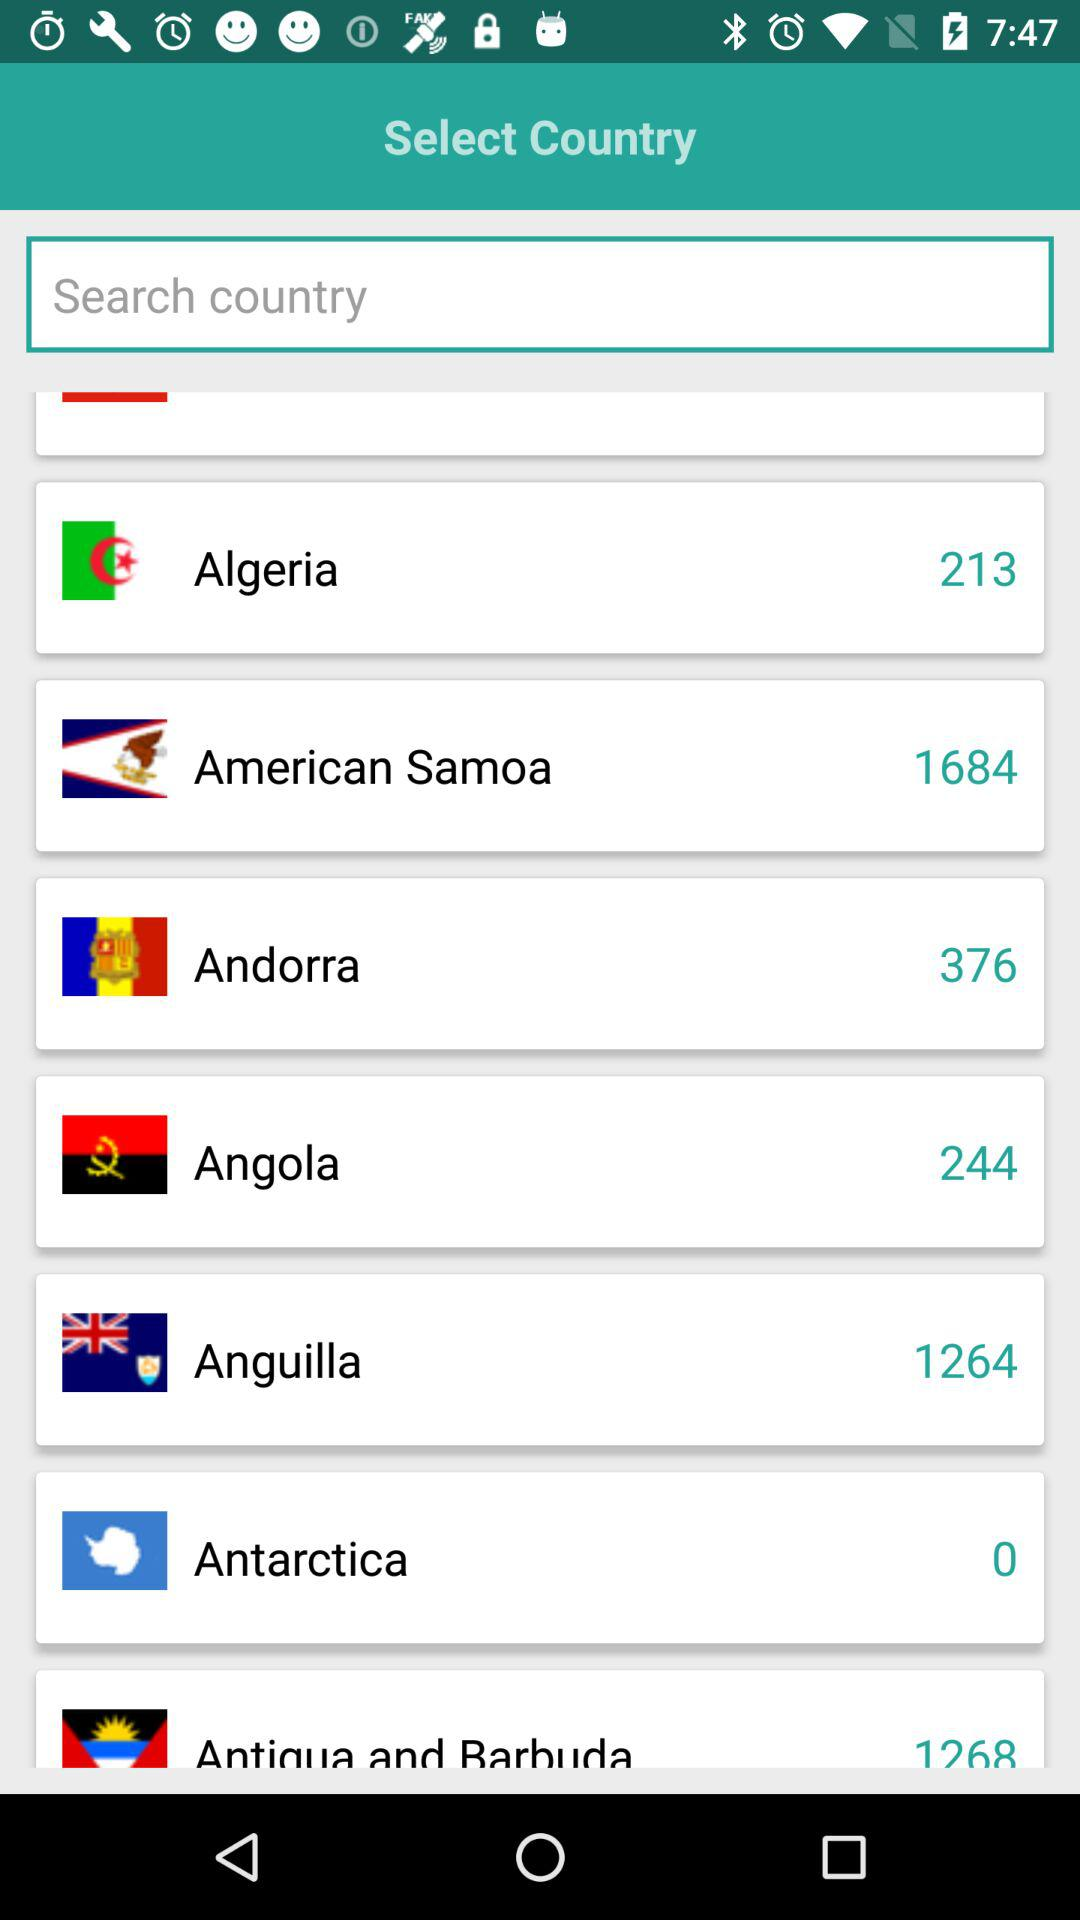What is Algeria's country code? Algeria's country code is 213. 